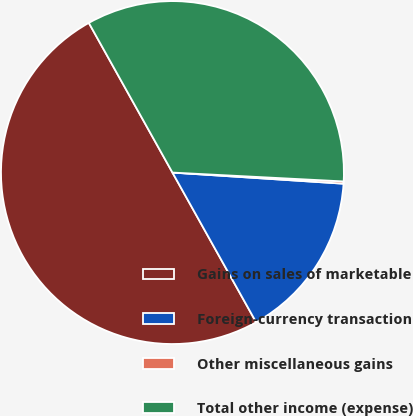Convert chart to OTSL. <chart><loc_0><loc_0><loc_500><loc_500><pie_chart><fcel>Gains on sales of marketable<fcel>Foreign-currency transaction<fcel>Other miscellaneous gains<fcel>Total other income (expense)<nl><fcel>50.0%<fcel>15.85%<fcel>0.21%<fcel>33.93%<nl></chart> 